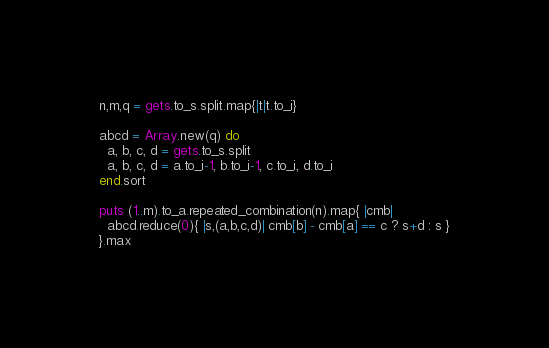<code> <loc_0><loc_0><loc_500><loc_500><_Ruby_>n,m,q = gets.to_s.split.map{|t|t.to_i}

abcd = Array.new(q) do
  a, b, c, d = gets.to_s.split
  a, b, c, d = a.to_i-1, b.to_i-1, c.to_i, d.to_i
end.sort

puts (1..m).to_a.repeated_combination(n).map{ |cmb| 
  abcd.reduce(0){ |s,(a,b,c,d)| cmb[b] - cmb[a] == c ? s+d : s }
}.max</code> 